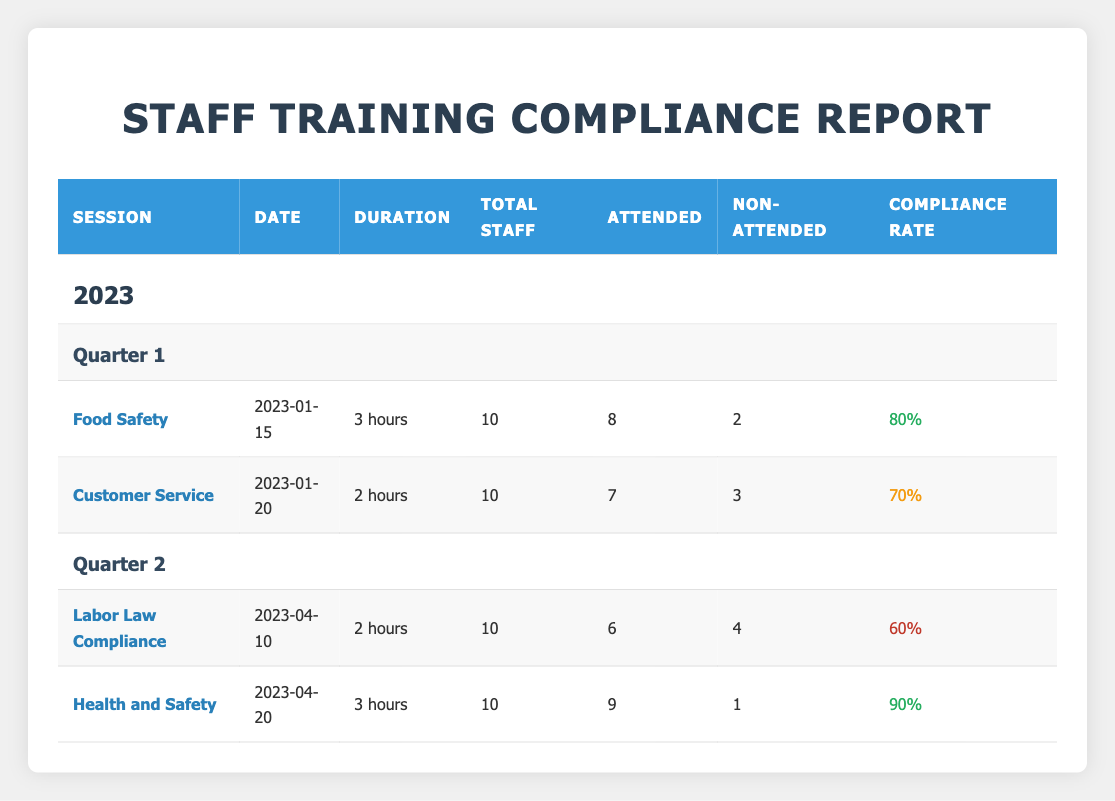What is the date of the Food Safety training session? The date of the Food Safety training session is listed directly in the table under its corresponding row in the Date column.
Answer: 2023-01-15 How many staff attended the Health and Safety training session? The number of staff who attended the Health and Safety training session is given in the Attendance column for that session.
Answer: 9 What is the compliance rate for the Labor Law Compliance training? The compliance rate for the Labor Law Compliance training session is mentioned in the Compliance Rate column next to that session.
Answer: 60% Which training session had the lowest attendance, and what was its compliance rate? To find the lowest attendance, we compare the Attended values for all sessions. The Labor Law Compliance session had 6 attendees, and its compliance rate is also noted in the table.
Answer: Labor Law Compliance, 60% What is the total number of staff who did not attend the training sessions in Quarter 1? We need to add the Non-Attended values for both sessions in Quarter 1. (2 for Food Safety + 3 for Customer Service) gives a total of 5 non-attended.
Answer: 5 Was the compliance rate for customer service training higher than 60%? We check the compliance rate for the Customer Service training, which is provided in the table. Since it is 70%, it is indeed higher than 60%.
Answer: Yes What is the difference in compliance rates between the Health and Safety session and the Labor Law Compliance session? We subtract the compliance rate of Labor Law Compliance (60%) from that of Health and Safety (90%). This gives us 90% - 60% = 30%.
Answer: 30% How many total staff attended the training sessions in Quarter 2? We sum the values of Attended for both sessions in Quarter 2. (6 for Labor Law Compliance + 9 for Health and Safety) totals 15 attendees.
Answer: 15 Which session had the highest compliance rate, and what was that rate? We evaluate the compliance rates listed in the table. The Health and Safety session had the highest compliance rate at 90%.
Answer: Health and Safety, 90% 